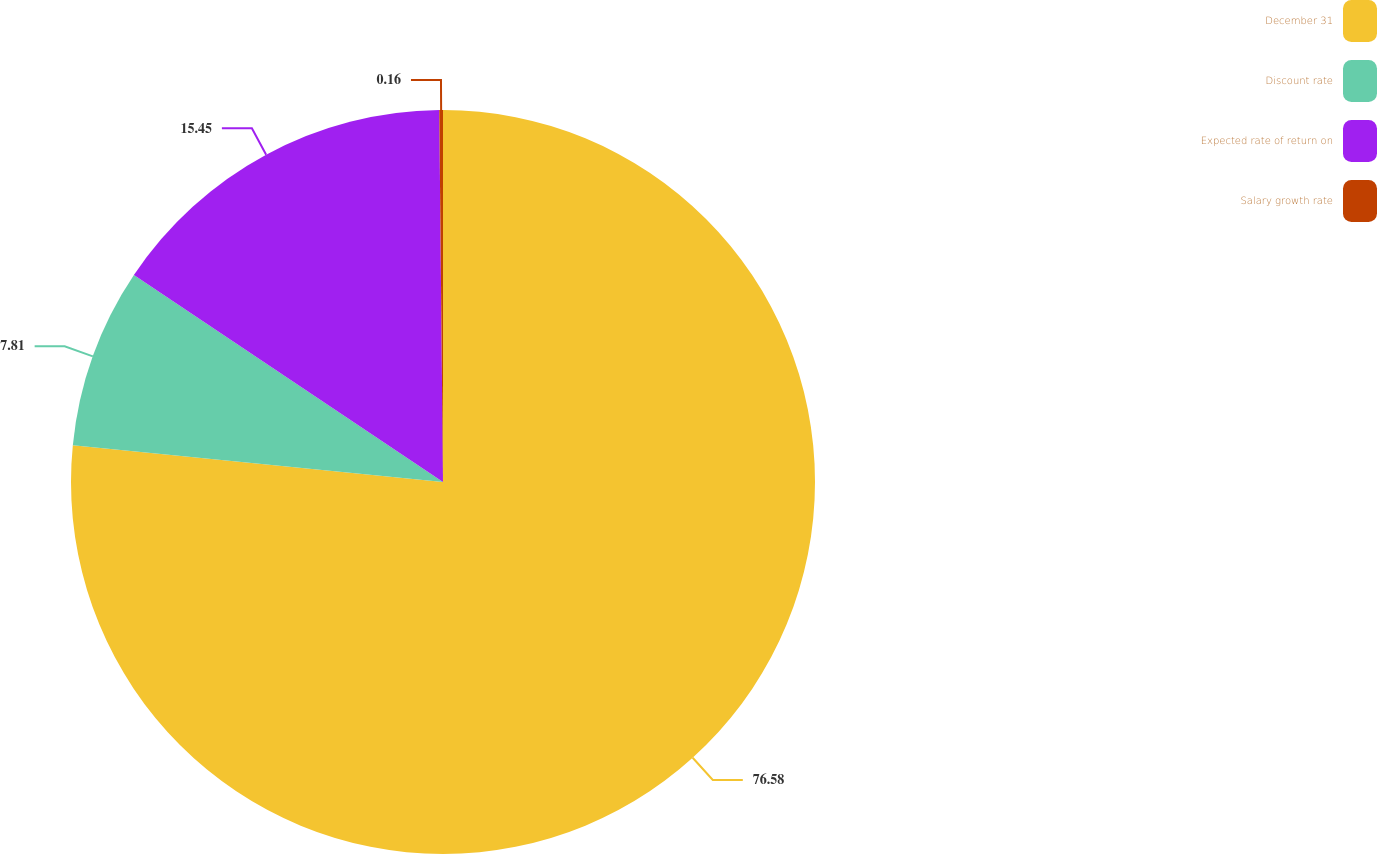Convert chart. <chart><loc_0><loc_0><loc_500><loc_500><pie_chart><fcel>December 31<fcel>Discount rate<fcel>Expected rate of return on<fcel>Salary growth rate<nl><fcel>76.58%<fcel>7.81%<fcel>15.45%<fcel>0.16%<nl></chart> 